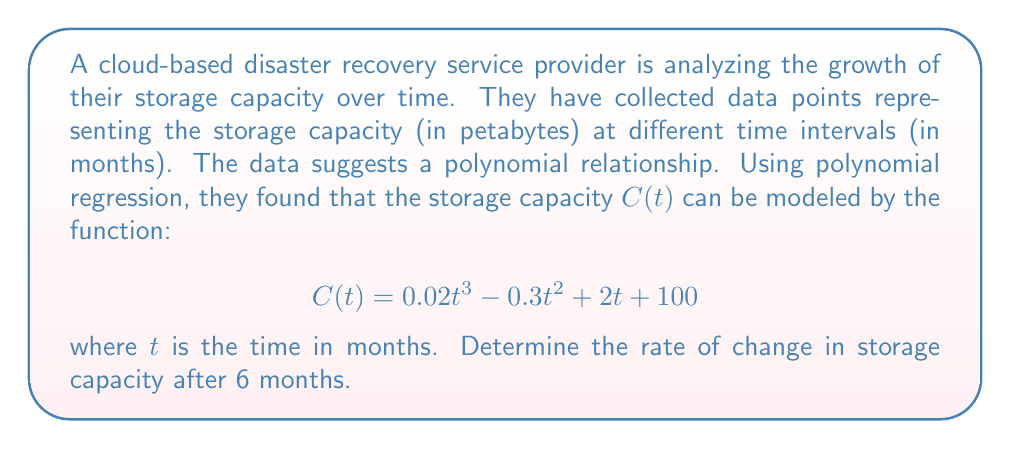Teach me how to tackle this problem. To find the rate of change in storage capacity, we need to calculate the derivative of the function $C(t)$ and then evaluate it at $t = 6$.

1. First, let's find the derivative of $C(t)$:
   
   $$C'(t) = \frac{d}{dt}(0.02t^3 - 0.3t^2 + 2t + 100)$$
   
   Using the power rule of differentiation:
   
   $$C'(t) = 0.06t^2 - 0.6t + 2$$

2. Now, we need to evaluate $C'(6)$:
   
   $$C'(6) = 0.06(6)^2 - 0.6(6) + 2$$
   
   $$C'(6) = 0.06(36) - 3.6 + 2$$
   
   $$C'(6) = 2.16 - 3.6 + 2$$
   
   $$C'(6) = 0.56$$

3. The rate of change is measured in petabytes per month, as time $t$ is in months and capacity $C$ is in petabytes.

Therefore, after 6 months, the rate of change in storage capacity is 0.56 petabytes per month.
Answer: 0.56 petabytes per month 